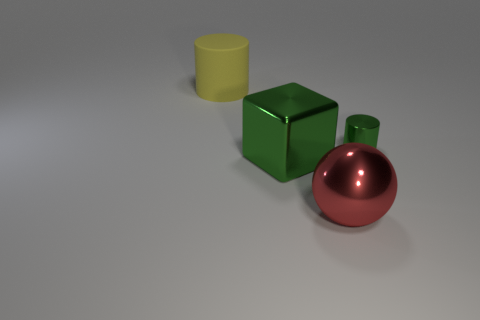Add 2 tiny gray rubber blocks. How many objects exist? 6 Subtract all cubes. How many objects are left? 3 Add 1 big yellow rubber objects. How many big yellow rubber objects exist? 2 Subtract 1 green blocks. How many objects are left? 3 Subtract all red things. Subtract all small green things. How many objects are left? 2 Add 1 small green metallic cylinders. How many small green metallic cylinders are left? 2 